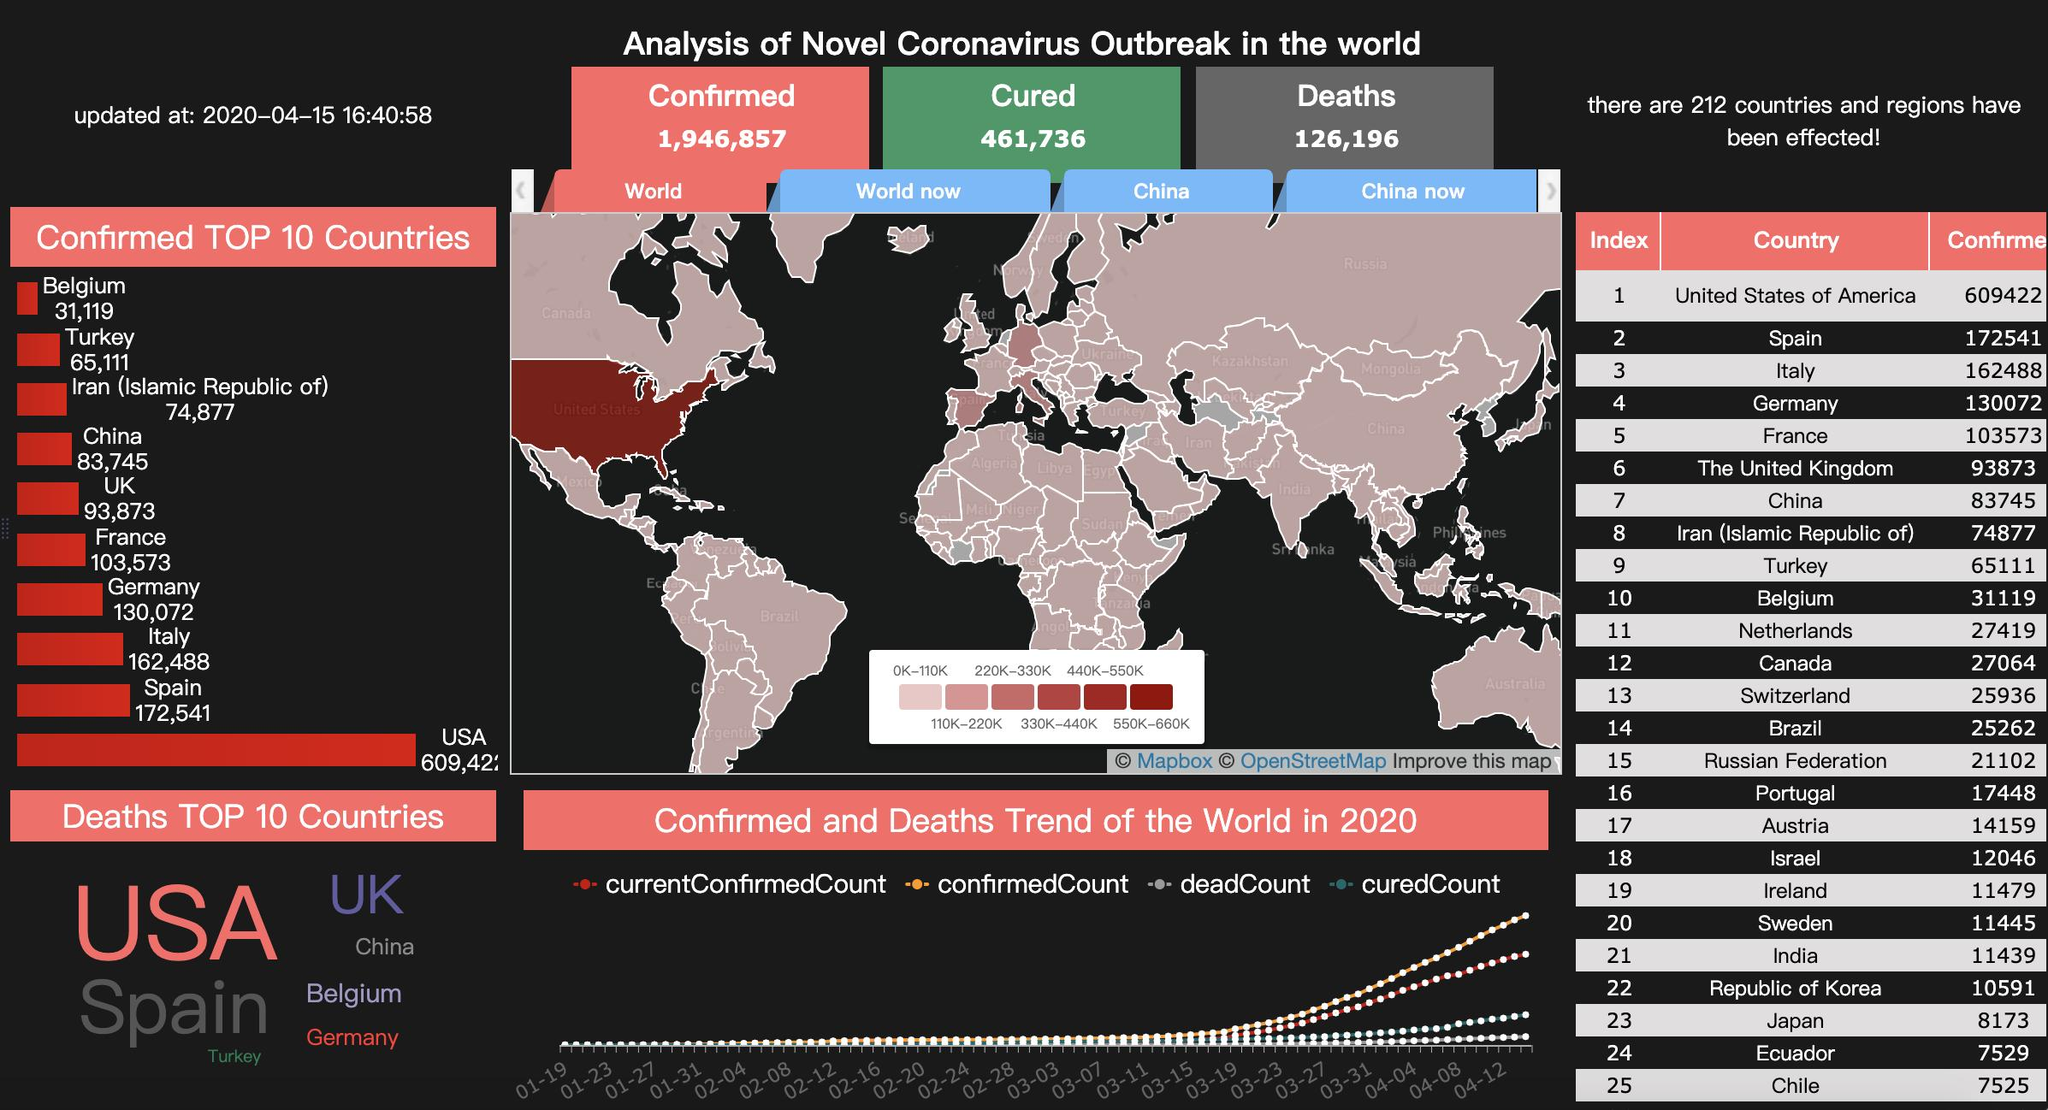List a handful of essential elements in this visual. The United States has experienced the highest number of deaths due to the COVID-19 pandemic. The total number of deaths in South American countries is 40,316. The total number of deaths in Italy and Spain together is 335029. Eighteen South American countries have been listed, including Brazil, Ecuador, and Chile. Of the 25 countries listed, Japan, Ecuador, and Chile have recorded fewer than 10,000 deaths. 